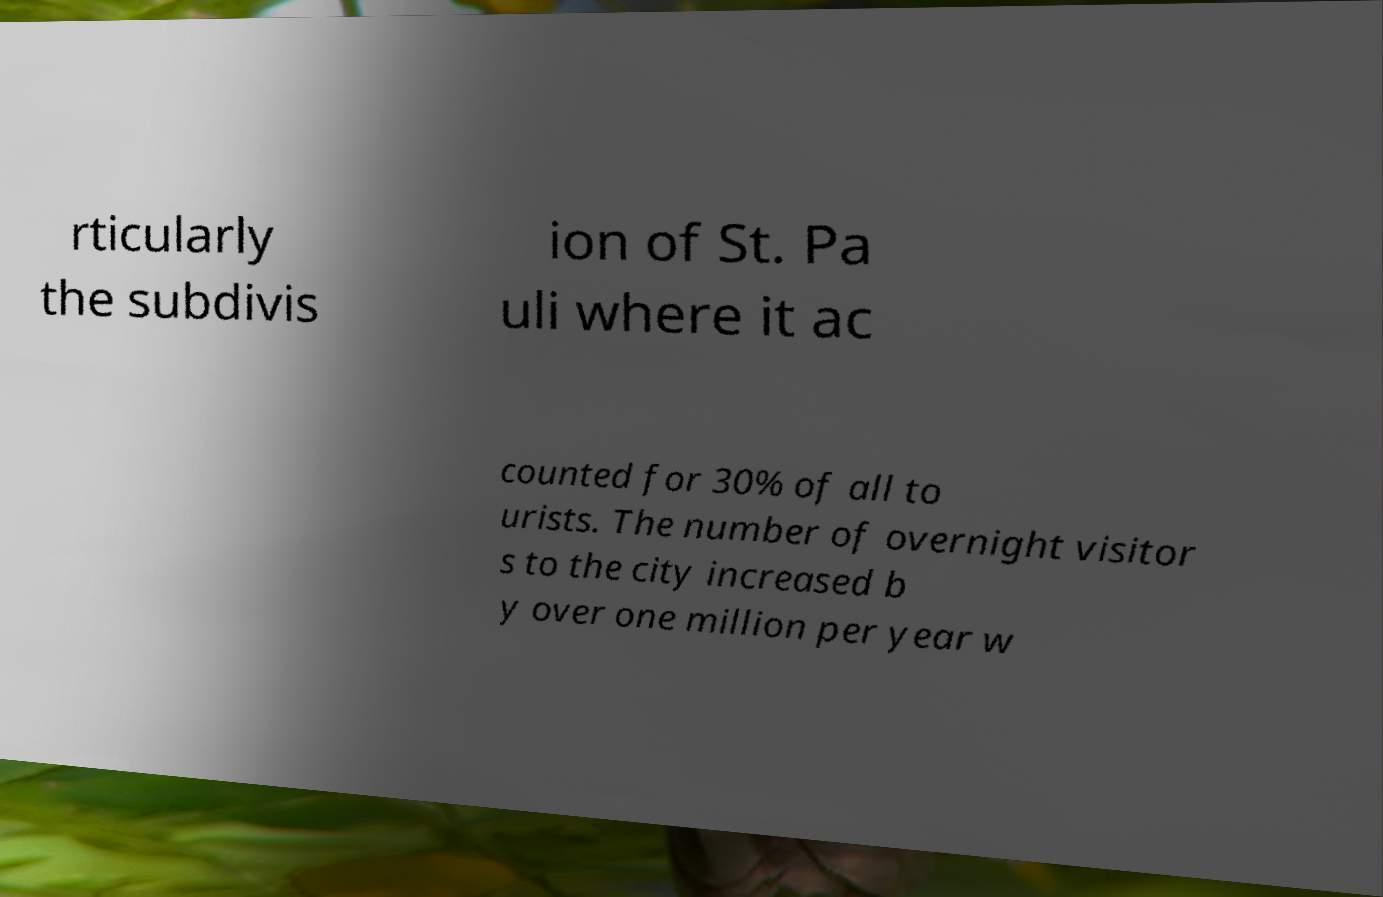Can you accurately transcribe the text from the provided image for me? rticularly the subdivis ion of St. Pa uli where it ac counted for 30% of all to urists. The number of overnight visitor s to the city increased b y over one million per year w 